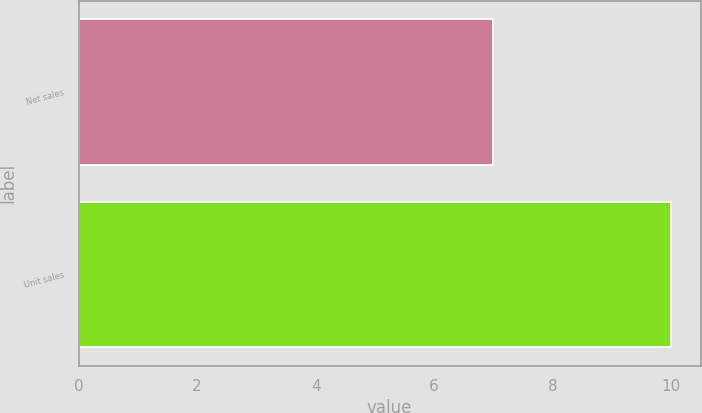<chart> <loc_0><loc_0><loc_500><loc_500><bar_chart><fcel>Net sales<fcel>Unit sales<nl><fcel>7<fcel>10<nl></chart> 